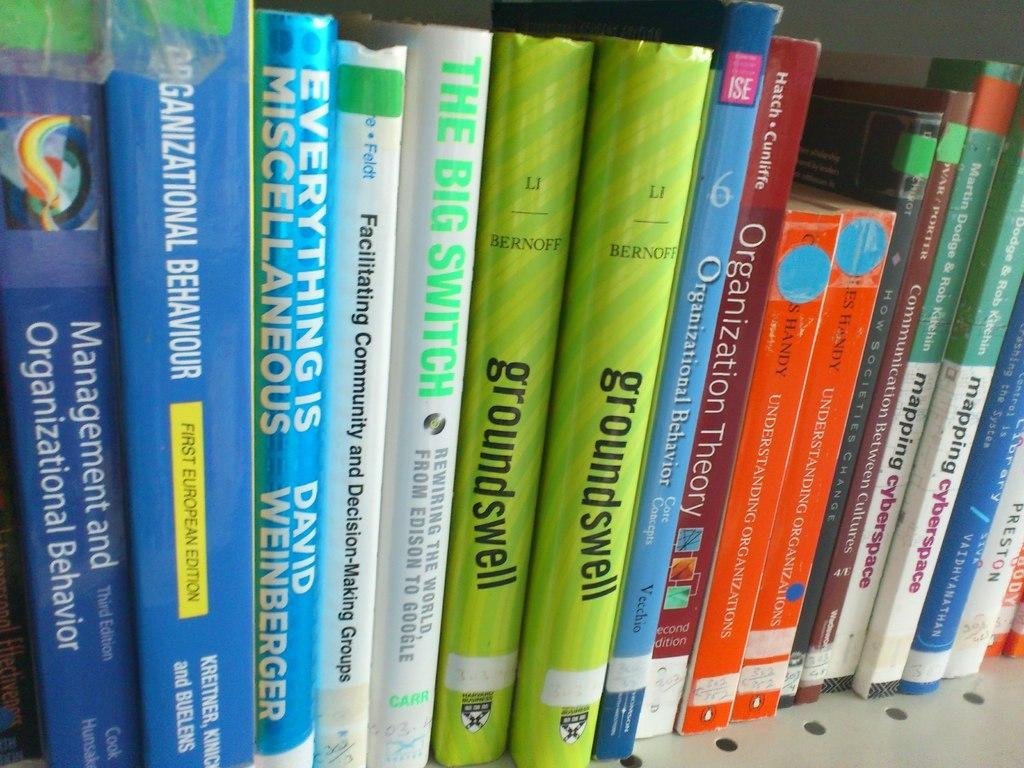<image>
Describe the image concisely. A bookshelf features books on organizational behavior and one called Groundswell. 